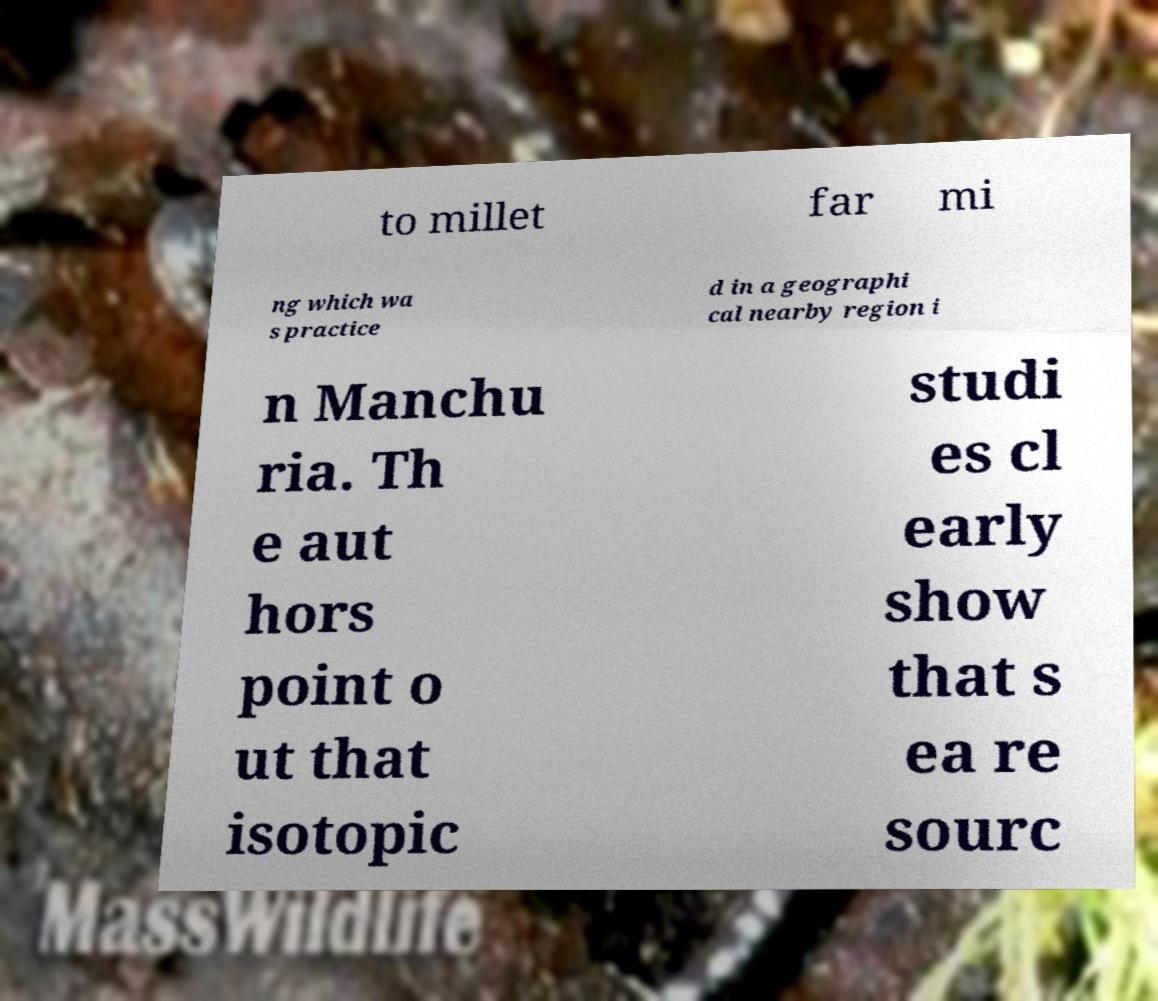There's text embedded in this image that I need extracted. Can you transcribe it verbatim? to millet far mi ng which wa s practice d in a geographi cal nearby region i n Manchu ria. Th e aut hors point o ut that isotopic studi es cl early show that s ea re sourc 